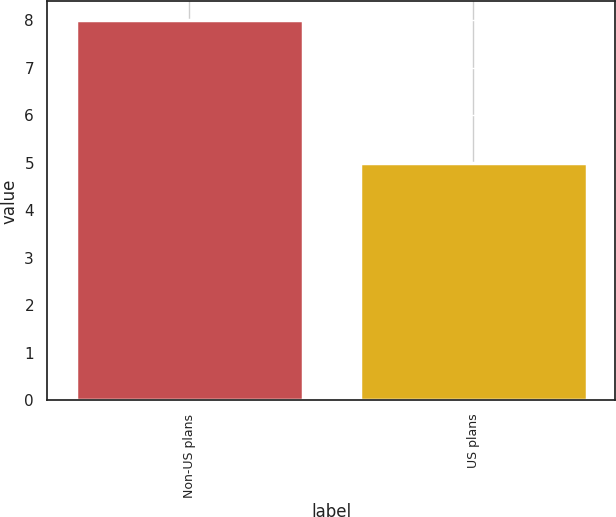Convert chart to OTSL. <chart><loc_0><loc_0><loc_500><loc_500><bar_chart><fcel>Non-US plans<fcel>US plans<nl><fcel>8<fcel>5<nl></chart> 